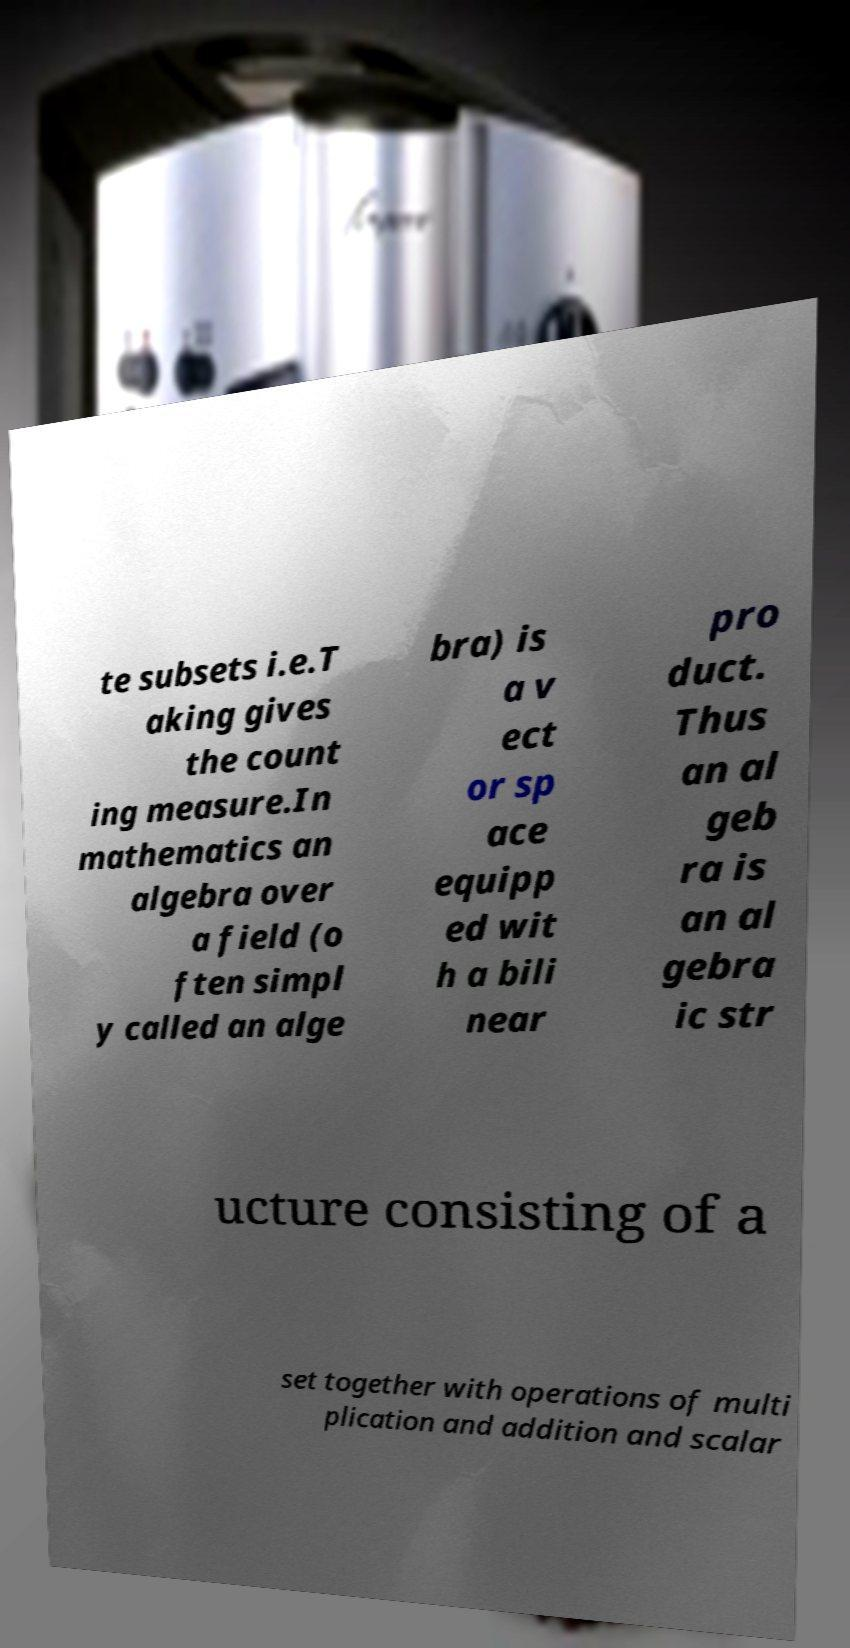What messages or text are displayed in this image? I need them in a readable, typed format. te subsets i.e.T aking gives the count ing measure.In mathematics an algebra over a field (o ften simpl y called an alge bra) is a v ect or sp ace equipp ed wit h a bili near pro duct. Thus an al geb ra is an al gebra ic str ucture consisting of a set together with operations of multi plication and addition and scalar 